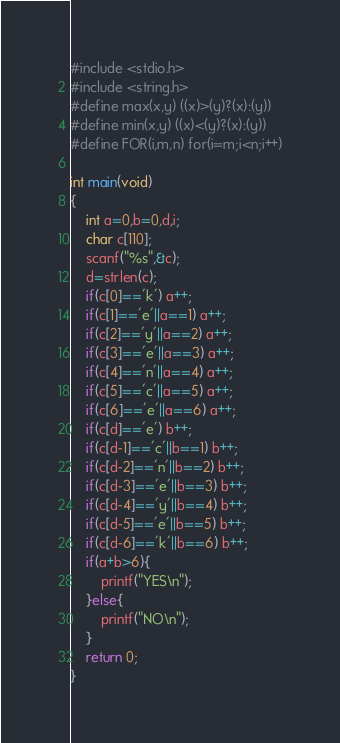Convert code to text. <code><loc_0><loc_0><loc_500><loc_500><_C_>#include <stdio.h>
#include <string.h>
#define max(x,y) ((x)>(y)?(x):(y))
#define min(x,y) ((x)<(y)?(x):(y))
#define FOR(i,m,n) for(i=m;i<n;i++)

int main(void)
{
	int a=0,b=0,d,i;
	char c[110];
	scanf("%s",&c);
	d=strlen(c);
	if(c[0]=='k') a++;
	if(c[1]=='e'||a==1) a++;
	if(c[2]=='y'||a==2) a++;
	if(c[3]=='e'||a==3) a++;
	if(c[4]=='n'||a==4) a++;
	if(c[5]=='c'||a==5) a++;
	if(c[6]=='e'||a==6) a++;
	if(c[d]=='e') b++;
	if(c[d-1]=='c'||b==1) b++;
	if(c[d-2]=='n'||b==2) b++;
	if(c[d-3]=='e'||b==3) b++;
	if(c[d-4]=='y'||b==4) b++;
	if(c[d-5]=='e'||b==5) b++;
	if(c[d-6]=='k'||b==6) b++;
	if(a+b>6){
		printf("YES\n");
	}else{
		printf("NO\n");
	}
	return 0;
}</code> 